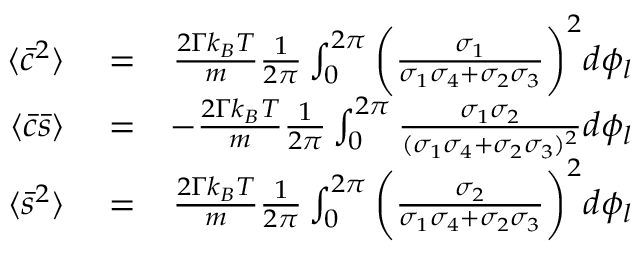<formula> <loc_0><loc_0><loc_500><loc_500>\begin{array} { r l r } { \langle \bar { c } ^ { 2 } \rangle } & = } & { \frac { 2 \Gamma k _ { B } T } { m } \frac { 1 } { 2 \pi } \int _ { 0 } ^ { 2 \pi } \left ( \frac { \sigma _ { 1 } } { \sigma _ { 1 } \sigma _ { 4 } + \sigma _ { 2 } \sigma _ { 3 } } \right ) ^ { 2 } d \phi _ { l } } \\ { \langle \bar { c } \bar { s } \rangle } & = } & { - \frac { 2 \Gamma k _ { B } T } { m } \frac { 1 } { 2 \pi } \int _ { 0 } ^ { 2 \pi } \frac { \sigma _ { 1 } \sigma _ { 2 } } { ( \sigma _ { 1 } \sigma _ { 4 } + \sigma _ { 2 } \sigma _ { 3 } ) ^ { 2 } } d \phi _ { l } } \\ { \langle \bar { s } ^ { 2 } \rangle } & = } & { \frac { 2 \Gamma k _ { B } T } { m } \frac { 1 } { 2 \pi } \int _ { 0 } ^ { 2 \pi } \left ( \frac { \sigma _ { 2 } } { \sigma _ { 1 } \sigma _ { 4 } + \sigma _ { 2 } \sigma _ { 3 } } \right ) ^ { 2 } d \phi _ { l } } \end{array}</formula> 